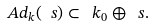Convert formula to latex. <formula><loc_0><loc_0><loc_500><loc_500>A d _ { k } ( \ s ) \subset \ k _ { 0 } \oplus \ s .</formula> 